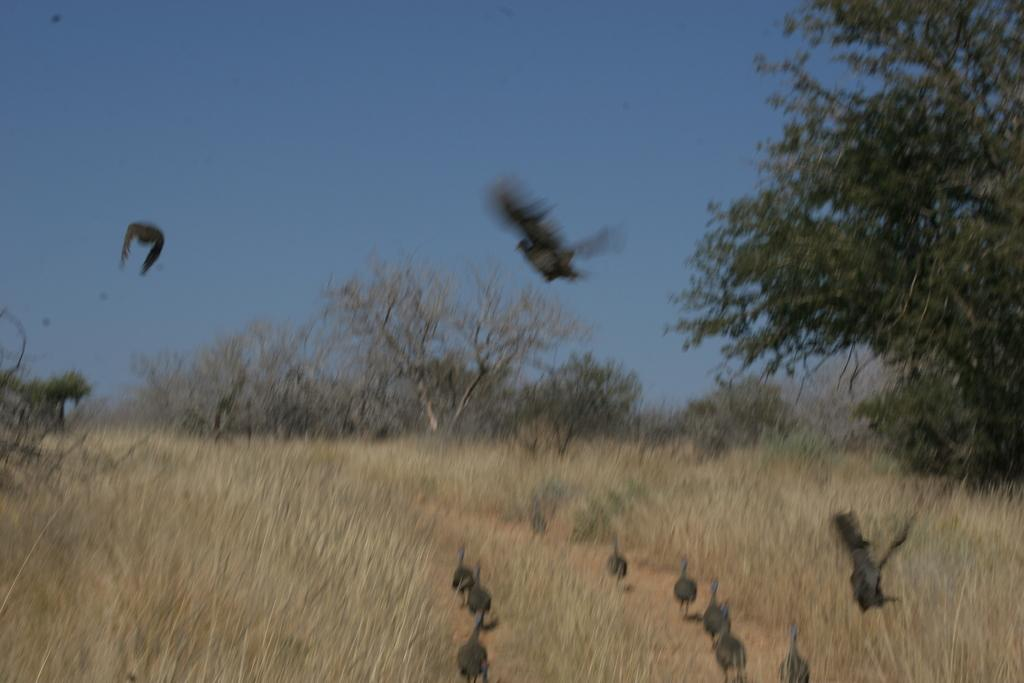What type of vegetation is present in the image? There is grass in the image. What animals can be seen in the image? There are birds in the image. What can be seen in the background of the image? There are trees and the sky visible in the background of the image. What is the purpose of the pencil in the image? There is no pencil present in the image. What type of thread is being used by the birds in the image? There are no birds using thread in the image. 